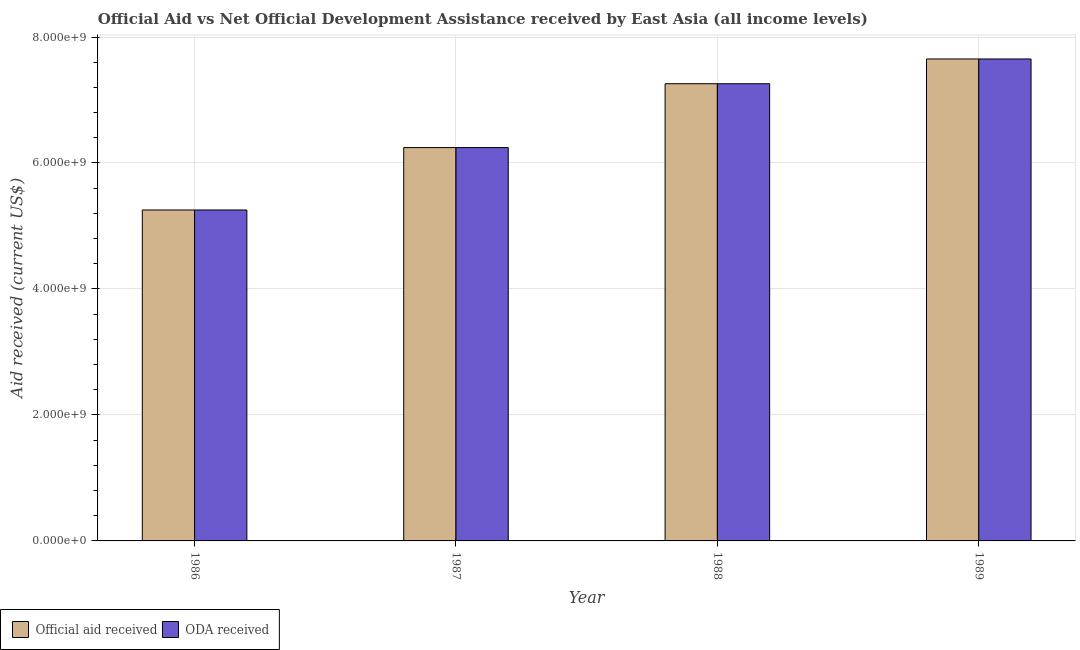How many different coloured bars are there?
Give a very brief answer. 2. Are the number of bars on each tick of the X-axis equal?
Offer a terse response. Yes. How many bars are there on the 3rd tick from the right?
Keep it short and to the point. 2. In how many cases, is the number of bars for a given year not equal to the number of legend labels?
Your answer should be very brief. 0. What is the oda received in 1986?
Ensure brevity in your answer.  5.25e+09. Across all years, what is the maximum oda received?
Offer a very short reply. 7.65e+09. Across all years, what is the minimum official aid received?
Keep it short and to the point. 5.25e+09. What is the total official aid received in the graph?
Offer a terse response. 2.64e+1. What is the difference between the oda received in 1986 and that in 1988?
Your response must be concise. -2.00e+09. What is the difference between the oda received in 1986 and the official aid received in 1989?
Offer a terse response. -2.40e+09. What is the average official aid received per year?
Offer a terse response. 6.60e+09. In how many years, is the official aid received greater than 6800000000 US$?
Provide a short and direct response. 2. What is the ratio of the official aid received in 1987 to that in 1989?
Give a very brief answer. 0.82. Is the difference between the oda received in 1986 and 1989 greater than the difference between the official aid received in 1986 and 1989?
Give a very brief answer. No. What is the difference between the highest and the second highest oda received?
Keep it short and to the point. 3.93e+08. What is the difference between the highest and the lowest official aid received?
Your answer should be compact. 2.40e+09. What does the 1st bar from the left in 1986 represents?
Offer a terse response. Official aid received. What does the 2nd bar from the right in 1986 represents?
Your response must be concise. Official aid received. How many bars are there?
Your answer should be very brief. 8. Are all the bars in the graph horizontal?
Your answer should be compact. No. How many years are there in the graph?
Provide a short and direct response. 4. What is the difference between two consecutive major ticks on the Y-axis?
Give a very brief answer. 2.00e+09. Are the values on the major ticks of Y-axis written in scientific E-notation?
Your answer should be very brief. Yes. Does the graph contain any zero values?
Offer a very short reply. No. Where does the legend appear in the graph?
Your response must be concise. Bottom left. How are the legend labels stacked?
Your answer should be compact. Horizontal. What is the title of the graph?
Offer a very short reply. Official Aid vs Net Official Development Assistance received by East Asia (all income levels) . What is the label or title of the X-axis?
Offer a terse response. Year. What is the label or title of the Y-axis?
Ensure brevity in your answer.  Aid received (current US$). What is the Aid received (current US$) in Official aid received in 1986?
Give a very brief answer. 5.25e+09. What is the Aid received (current US$) in ODA received in 1986?
Make the answer very short. 5.25e+09. What is the Aid received (current US$) of Official aid received in 1987?
Offer a very short reply. 6.24e+09. What is the Aid received (current US$) of ODA received in 1987?
Give a very brief answer. 6.24e+09. What is the Aid received (current US$) of Official aid received in 1988?
Offer a terse response. 7.26e+09. What is the Aid received (current US$) in ODA received in 1988?
Provide a short and direct response. 7.26e+09. What is the Aid received (current US$) of Official aid received in 1989?
Provide a succinct answer. 7.65e+09. What is the Aid received (current US$) of ODA received in 1989?
Make the answer very short. 7.65e+09. Across all years, what is the maximum Aid received (current US$) in Official aid received?
Offer a terse response. 7.65e+09. Across all years, what is the maximum Aid received (current US$) in ODA received?
Keep it short and to the point. 7.65e+09. Across all years, what is the minimum Aid received (current US$) of Official aid received?
Make the answer very short. 5.25e+09. Across all years, what is the minimum Aid received (current US$) of ODA received?
Ensure brevity in your answer.  5.25e+09. What is the total Aid received (current US$) of Official aid received in the graph?
Provide a succinct answer. 2.64e+1. What is the total Aid received (current US$) in ODA received in the graph?
Your answer should be compact. 2.64e+1. What is the difference between the Aid received (current US$) of Official aid received in 1986 and that in 1987?
Your response must be concise. -9.91e+08. What is the difference between the Aid received (current US$) in ODA received in 1986 and that in 1987?
Provide a succinct answer. -9.91e+08. What is the difference between the Aid received (current US$) in Official aid received in 1986 and that in 1988?
Your answer should be compact. -2.00e+09. What is the difference between the Aid received (current US$) of ODA received in 1986 and that in 1988?
Make the answer very short. -2.00e+09. What is the difference between the Aid received (current US$) in Official aid received in 1986 and that in 1989?
Make the answer very short. -2.40e+09. What is the difference between the Aid received (current US$) of ODA received in 1986 and that in 1989?
Make the answer very short. -2.40e+09. What is the difference between the Aid received (current US$) in Official aid received in 1987 and that in 1988?
Make the answer very short. -1.01e+09. What is the difference between the Aid received (current US$) in ODA received in 1987 and that in 1988?
Offer a very short reply. -1.01e+09. What is the difference between the Aid received (current US$) of Official aid received in 1987 and that in 1989?
Your response must be concise. -1.41e+09. What is the difference between the Aid received (current US$) in ODA received in 1987 and that in 1989?
Give a very brief answer. -1.41e+09. What is the difference between the Aid received (current US$) in Official aid received in 1988 and that in 1989?
Ensure brevity in your answer.  -3.93e+08. What is the difference between the Aid received (current US$) of ODA received in 1988 and that in 1989?
Your response must be concise. -3.93e+08. What is the difference between the Aid received (current US$) in Official aid received in 1986 and the Aid received (current US$) in ODA received in 1987?
Your response must be concise. -9.91e+08. What is the difference between the Aid received (current US$) of Official aid received in 1986 and the Aid received (current US$) of ODA received in 1988?
Your answer should be compact. -2.00e+09. What is the difference between the Aid received (current US$) of Official aid received in 1986 and the Aid received (current US$) of ODA received in 1989?
Your response must be concise. -2.40e+09. What is the difference between the Aid received (current US$) in Official aid received in 1987 and the Aid received (current US$) in ODA received in 1988?
Offer a very short reply. -1.01e+09. What is the difference between the Aid received (current US$) in Official aid received in 1987 and the Aid received (current US$) in ODA received in 1989?
Offer a terse response. -1.41e+09. What is the difference between the Aid received (current US$) in Official aid received in 1988 and the Aid received (current US$) in ODA received in 1989?
Ensure brevity in your answer.  -3.93e+08. What is the average Aid received (current US$) of Official aid received per year?
Give a very brief answer. 6.60e+09. What is the average Aid received (current US$) of ODA received per year?
Provide a short and direct response. 6.60e+09. In the year 1986, what is the difference between the Aid received (current US$) of Official aid received and Aid received (current US$) of ODA received?
Your response must be concise. 0. In the year 1987, what is the difference between the Aid received (current US$) in Official aid received and Aid received (current US$) in ODA received?
Your response must be concise. 0. In the year 1989, what is the difference between the Aid received (current US$) of Official aid received and Aid received (current US$) of ODA received?
Keep it short and to the point. 0. What is the ratio of the Aid received (current US$) in Official aid received in 1986 to that in 1987?
Offer a terse response. 0.84. What is the ratio of the Aid received (current US$) of ODA received in 1986 to that in 1987?
Provide a short and direct response. 0.84. What is the ratio of the Aid received (current US$) in Official aid received in 1986 to that in 1988?
Provide a succinct answer. 0.72. What is the ratio of the Aid received (current US$) in ODA received in 1986 to that in 1988?
Your response must be concise. 0.72. What is the ratio of the Aid received (current US$) in Official aid received in 1986 to that in 1989?
Provide a succinct answer. 0.69. What is the ratio of the Aid received (current US$) in ODA received in 1986 to that in 1989?
Your answer should be compact. 0.69. What is the ratio of the Aid received (current US$) in Official aid received in 1987 to that in 1988?
Your response must be concise. 0.86. What is the ratio of the Aid received (current US$) of ODA received in 1987 to that in 1988?
Provide a short and direct response. 0.86. What is the ratio of the Aid received (current US$) in Official aid received in 1987 to that in 1989?
Offer a terse response. 0.82. What is the ratio of the Aid received (current US$) in ODA received in 1987 to that in 1989?
Make the answer very short. 0.82. What is the ratio of the Aid received (current US$) of Official aid received in 1988 to that in 1989?
Keep it short and to the point. 0.95. What is the ratio of the Aid received (current US$) in ODA received in 1988 to that in 1989?
Ensure brevity in your answer.  0.95. What is the difference between the highest and the second highest Aid received (current US$) of Official aid received?
Give a very brief answer. 3.93e+08. What is the difference between the highest and the second highest Aid received (current US$) of ODA received?
Ensure brevity in your answer.  3.93e+08. What is the difference between the highest and the lowest Aid received (current US$) of Official aid received?
Make the answer very short. 2.40e+09. What is the difference between the highest and the lowest Aid received (current US$) of ODA received?
Offer a terse response. 2.40e+09. 